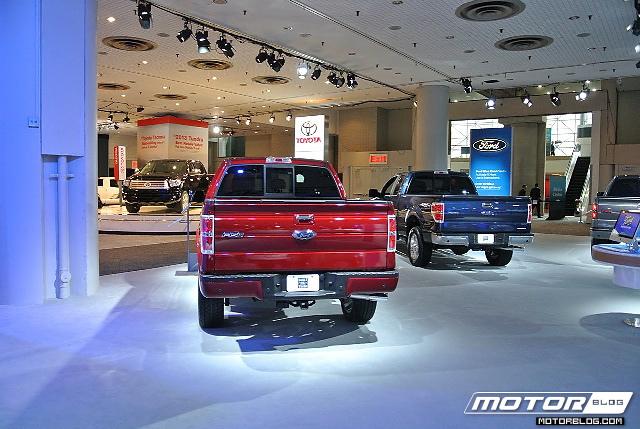What color is the closest truck?
Concise answer only. Red. What brand of cars is being sold here?
Quick response, please. Ford. Is this a showroom?
Be succinct. Yes. 